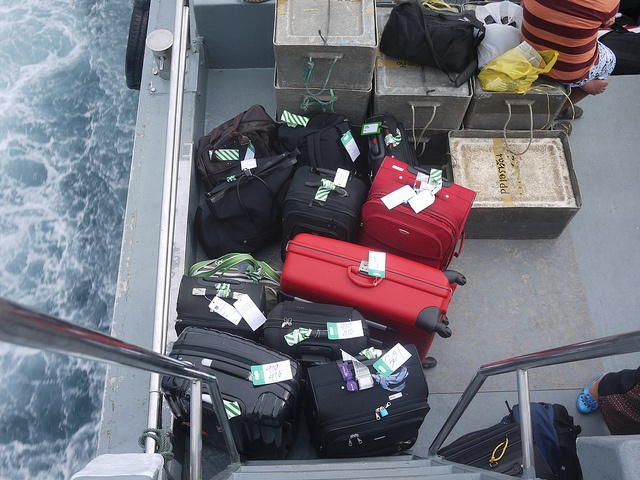Describe the objects in this image and their specific colors. I can see boat in black, darkgray, lightgray, and gray tones, suitcase in lightgray, salmon, black, maroon, and brown tones, suitcase in lightgray, black, white, and gray tones, suitcase in lightgray, black, gray, and white tones, and suitcase in lightgray, black, gray, navy, and darkgray tones in this image. 